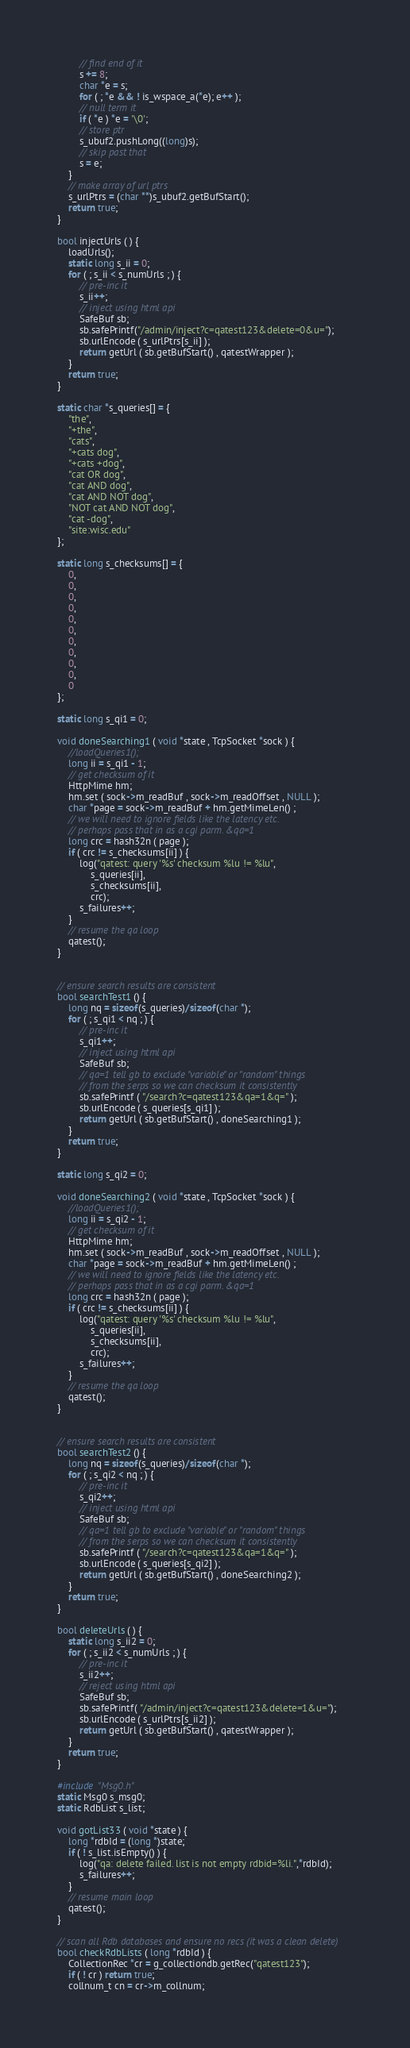<code> <loc_0><loc_0><loc_500><loc_500><_C++_>		// find end of it
		s += 8;
		char *e = s;
		for ( ; *e && ! is_wspace_a(*e); e++ );
		// null term it
		if ( *e ) *e = '\0';
		// store ptr
		s_ubuf2.pushLong((long)s);
		// skip past that
		s = e;
	}
	// make array of url ptrs
	s_urlPtrs = (char **)s_ubuf2.getBufStart();
	return true;
}

bool injectUrls ( ) {
	loadUrls();
	static long s_ii = 0;
	for ( ; s_ii < s_numUrls ; ) {
		// pre-inc it
		s_ii++;
		// inject using html api
		SafeBuf sb;
		sb.safePrintf("/admin/inject?c=qatest123&delete=0&u=");
		sb.urlEncode ( s_urlPtrs[s_ii] );
		return getUrl ( sb.getBufStart() , qatestWrapper );
	}
	return true;
}

static char *s_queries[] = {
	"the",
	"+the",
	"cats",
	"+cats dog",
	"+cats +dog",
	"cat OR dog",
	"cat AND dog",
	"cat AND NOT dog",
	"NOT cat AND NOT dog",
	"cat -dog",
	"site:wisc.edu"
};

static long s_checksums[] = {
	0,
	0,
	0,
	0,
	0,
	0,
	0,
	0,
	0,
	0,
	0
};

static long s_qi1 = 0;

void doneSearching1 ( void *state , TcpSocket *sock ) {
	//loadQueries1();
	long ii = s_qi1 - 1;
	// get checksum of it
	HttpMime hm;
	hm.set ( sock->m_readBuf , sock->m_readOffset , NULL );
	char *page = sock->m_readBuf + hm.getMimeLen() ;
	// we will need to ignore fields like the latency etc.
	// perhaps pass that in as a cgi parm. &qa=1
	long crc = hash32n ( page );
	if ( crc != s_checksums[ii] ) {
		log("qatest: query '%s' checksum %lu != %lu",
		    s_queries[ii],
		    s_checksums[ii],
		    crc);
		s_failures++;
	}
	// resume the qa loop
	qatest();
}
		

// ensure search results are consistent
bool searchTest1 () {
	long nq = sizeof(s_queries)/sizeof(char *);
	for ( ; s_qi1 < nq ; ) {
		// pre-inc it
		s_qi1++;
		// inject using html api
		SafeBuf sb;
		// qa=1 tell gb to exclude "variable" or "random" things
		// from the serps so we can checksum it consistently
		sb.safePrintf ( "/search?c=qatest123&qa=1&q=" );
		sb.urlEncode ( s_queries[s_qi1] );
		return getUrl ( sb.getBufStart() , doneSearching1 );
	}
	return true;
}	

static long s_qi2 = 0;

void doneSearching2 ( void *state , TcpSocket *sock ) {
	//loadQueries1();
	long ii = s_qi2 - 1;
	// get checksum of it
	HttpMime hm;
	hm.set ( sock->m_readBuf , sock->m_readOffset , NULL );
	char *page = sock->m_readBuf + hm.getMimeLen() ;
	// we will need to ignore fields like the latency etc.
	// perhaps pass that in as a cgi parm. &qa=1
	long crc = hash32n ( page );
	if ( crc != s_checksums[ii] ) {
		log("qatest: query '%s' checksum %lu != %lu",
		    s_queries[ii],
		    s_checksums[ii],
		    crc);
		s_failures++;
	}
	// resume the qa loop
	qatest();
}
		

// ensure search results are consistent
bool searchTest2 () {
	long nq = sizeof(s_queries)/sizeof(char *);
	for ( ; s_qi2 < nq ; ) {
		// pre-inc it
		s_qi2++;
		// inject using html api
		SafeBuf sb;
		// qa=1 tell gb to exclude "variable" or "random" things
		// from the serps so we can checksum it consistently
		sb.safePrintf ( "/search?c=qatest123&qa=1&q=" );
		sb.urlEncode ( s_queries[s_qi2] );
		return getUrl ( sb.getBufStart() , doneSearching2 );
	}
	return true;
}	

bool deleteUrls ( ) {
	static long s_ii2 = 0;
	for ( ; s_ii2 < s_numUrls ; ) {
		// pre-inc it
		s_ii2++;
		// reject using html api
		SafeBuf sb;
		sb.safePrintf( "/admin/inject?c=qatest123&delete=1&u=");
		sb.urlEncode ( s_urlPtrs[s_ii2] );
		return getUrl ( sb.getBufStart() , qatestWrapper );
	}
	return true;
}

#include "Msg0.h"
static Msg0 s_msg0;
static RdbList s_list;

void gotList33 ( void *state ) {
	long *rdbId = (long *)state;
	if ( ! s_list.isEmpty() ) {
		log("qa: delete failed. list is not empty rdbid=%li.",*rdbId);
		s_failures++;
	}
	// resume main loop
	qatest();
}

// scan all Rdb databases and ensure no recs (it was a clean delete)
bool checkRdbLists ( long *rdbId ) {
	CollectionRec *cr = g_collectiondb.getRec("qatest123");
	if ( ! cr ) return true;
	collnum_t cn = cr->m_collnum;</code> 